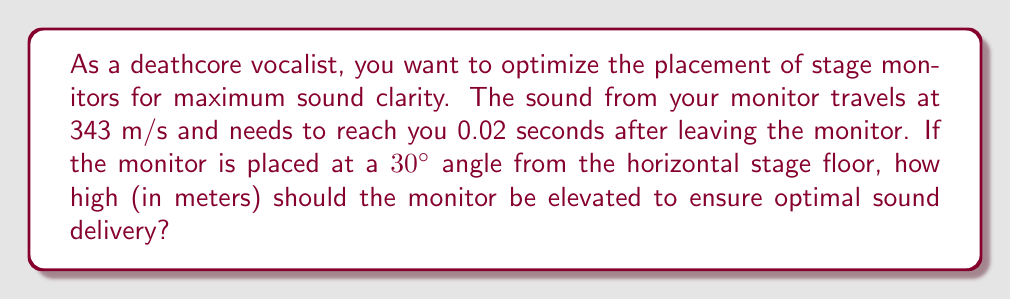Can you solve this math problem? Let's approach this step-by-step:

1) First, we need to calculate the distance the sound travels in 0.02 seconds:
   $$d = v \times t$$
   Where $v$ is velocity and $t$ is time
   $$d = 343 \text{ m/s} \times 0.02 \text{ s} = 6.86 \text{ m}$$

2) Now, we can use trigonometry to find the height. The monitor, its height, and the distance to the vocalist form a right triangle. The angle between the floor and the sound path is 30°.

3) We can use the sine function to find the height:
   $$\sin(30°) = \frac{\text{opposite}}{\text{hypotenuse}} = \frac{\text{height}}{6.86 \text{ m}}$$

4) Rearranging this equation:
   $$\text{height} = 6.86 \text{ m} \times \sin(30°)$$

5) Calculate:
   $$\text{height} = 6.86 \text{ m} \times 0.5 = 3.43 \text{ m}$$

Therefore, the monitor should be elevated 3.43 meters above the stage floor for optimal sound delivery.
Answer: 3.43 m 